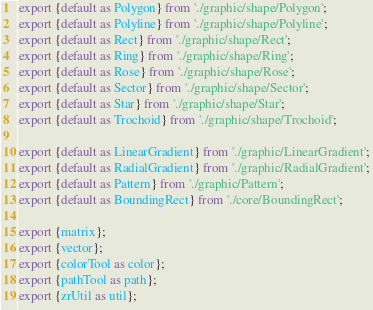Convert code to text. <code><loc_0><loc_0><loc_500><loc_500><_JavaScript_>export {default as Polygon} from './graphic/shape/Polygon';
export {default as Polyline} from './graphic/shape/Polyline';
export {default as Rect} from './graphic/shape/Rect';
export {default as Ring} from './graphic/shape/Ring';
export {default as Rose} from './graphic/shape/Rose';
export {default as Sector} from './graphic/shape/Sector';
export {default as Star} from './graphic/shape/Star';
export {default as Trochoid} from './graphic/shape/Trochoid';

export {default as LinearGradient} from './graphic/LinearGradient';
export {default as RadialGradient} from './graphic/RadialGradient';
export {default as Pattern} from './graphic/Pattern';
export {default as BoundingRect} from './core/BoundingRect';

export {matrix};
export {vector};
export {colorTool as color};
export {pathTool as path};
export {zrUtil as util};
</code> 